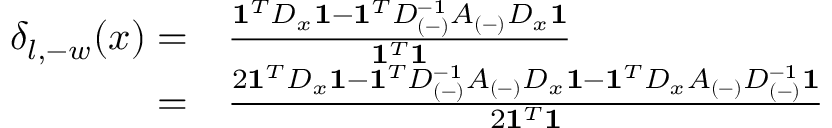Convert formula to latex. <formula><loc_0><loc_0><loc_500><loc_500>\begin{array} { r l } { \delta _ { l , - w } ( x ) = } & \frac { 1 ^ { T } D _ { x } 1 - 1 ^ { T } D _ { ( - ) } ^ { - 1 } A _ { ( - ) } D _ { x } 1 } { 1 ^ { T } 1 } } \\ { = } & \frac { 2 1 ^ { T } D _ { x } 1 - 1 ^ { T } D _ { ( - ) } ^ { - 1 } A _ { ( - ) } D _ { x } 1 - 1 ^ { T } D _ { x } A _ { ( - ) } D _ { ( - ) } ^ { - 1 } 1 } { 2 1 ^ { T } 1 } \, } \end{array}</formula> 